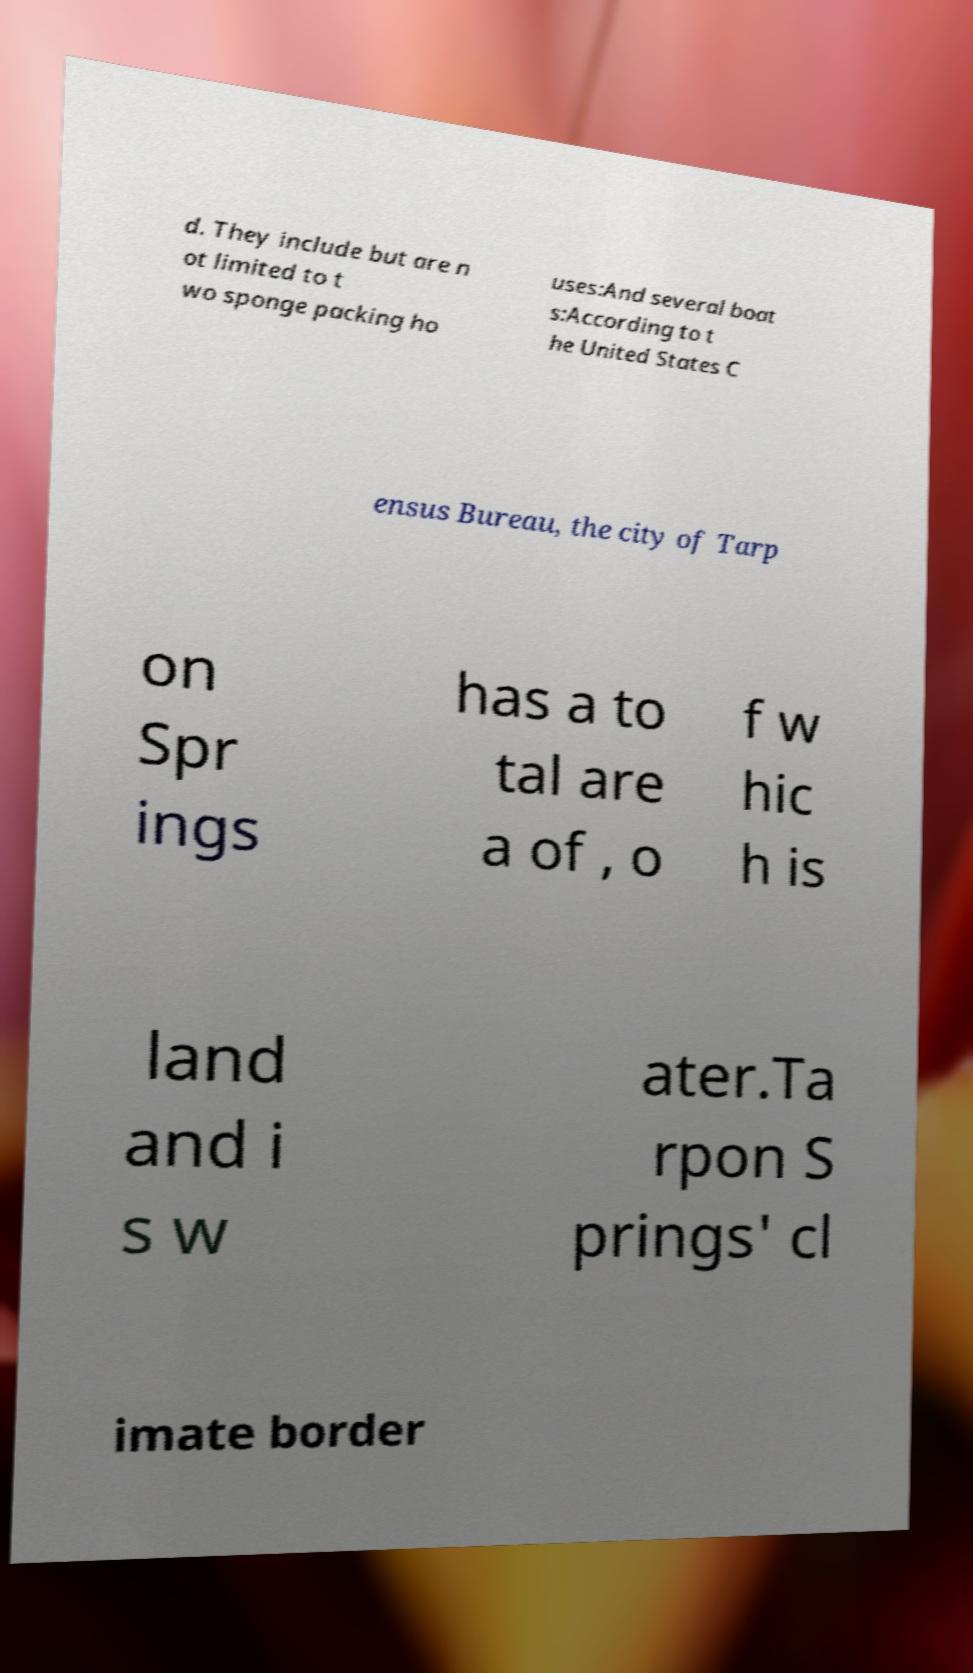Can you read and provide the text displayed in the image?This photo seems to have some interesting text. Can you extract and type it out for me? d. They include but are n ot limited to t wo sponge packing ho uses:And several boat s:According to t he United States C ensus Bureau, the city of Tarp on Spr ings has a to tal are a of , o f w hic h is land and i s w ater.Ta rpon S prings' cl imate border 